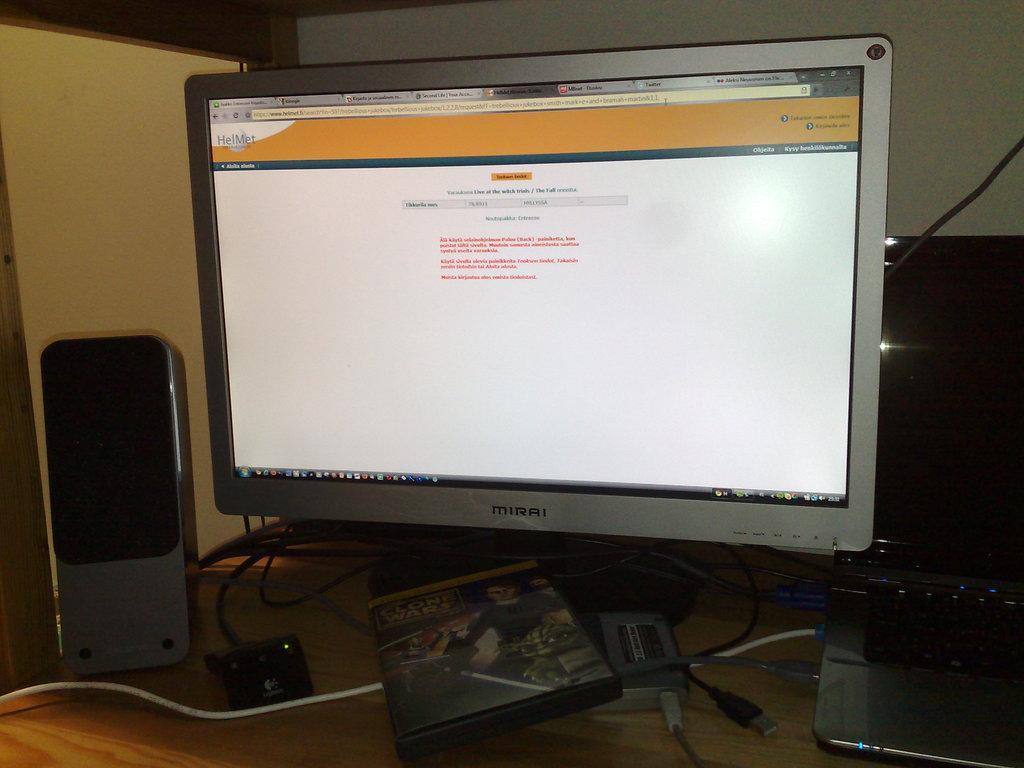Can you describe this image briefly? In this image I see a monitor and there are tabs opened in it and there is a site on the screen and I see a speaker over here, laptop and few wires and a thing over here. 